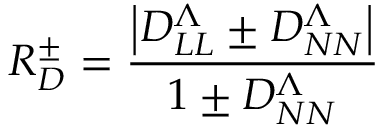<formula> <loc_0><loc_0><loc_500><loc_500>R _ { D } ^ { \pm } = \frac { \left | D _ { L L } ^ { \Lambda } \pm D _ { N N } ^ { \Lambda } \right | } { 1 \pm D _ { N N } ^ { \Lambda } }</formula> 